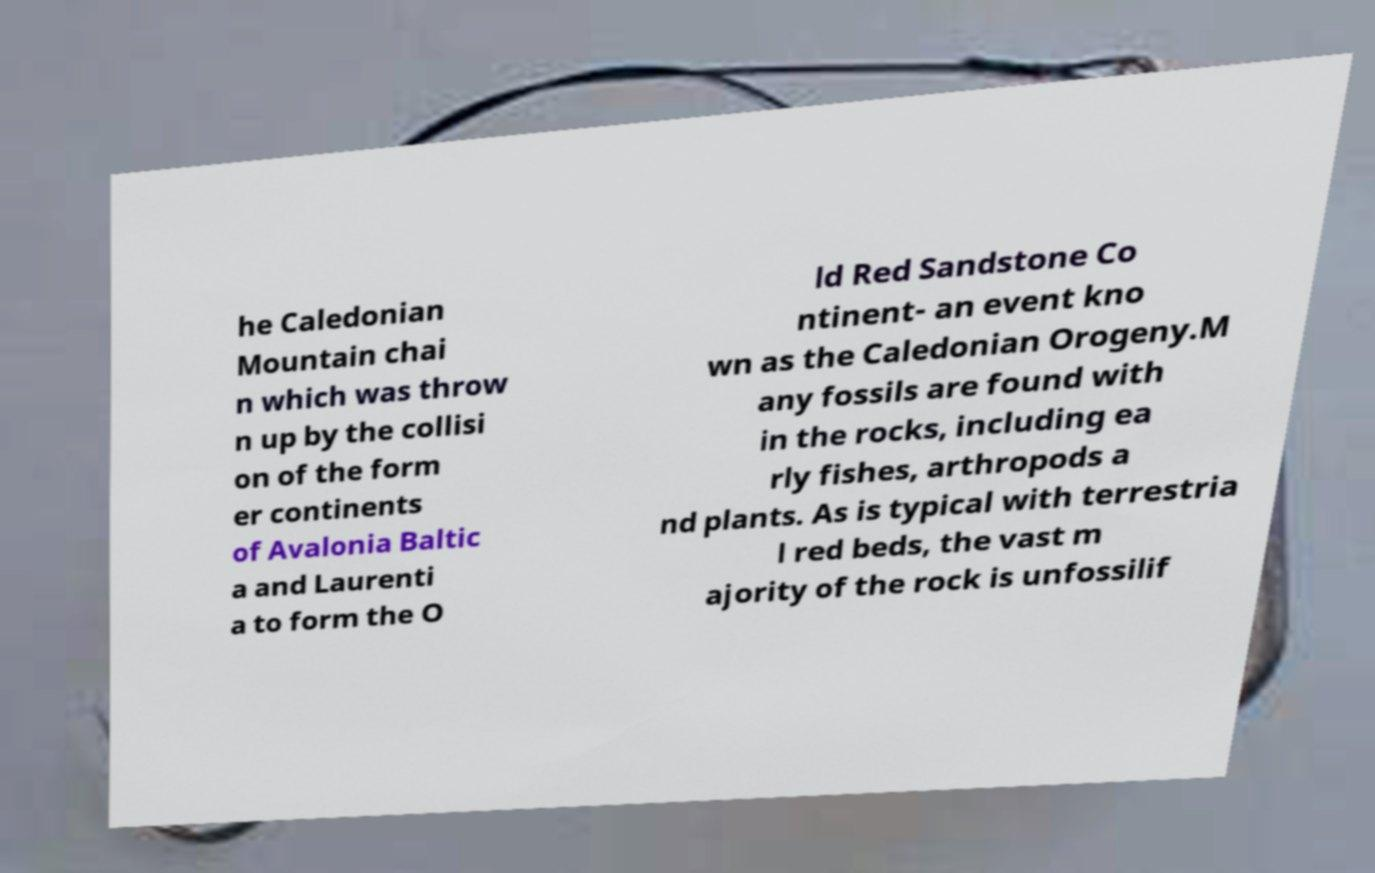Please identify and transcribe the text found in this image. he Caledonian Mountain chai n which was throw n up by the collisi on of the form er continents of Avalonia Baltic a and Laurenti a to form the O ld Red Sandstone Co ntinent- an event kno wn as the Caledonian Orogeny.M any fossils are found with in the rocks, including ea rly fishes, arthropods a nd plants. As is typical with terrestria l red beds, the vast m ajority of the rock is unfossilif 